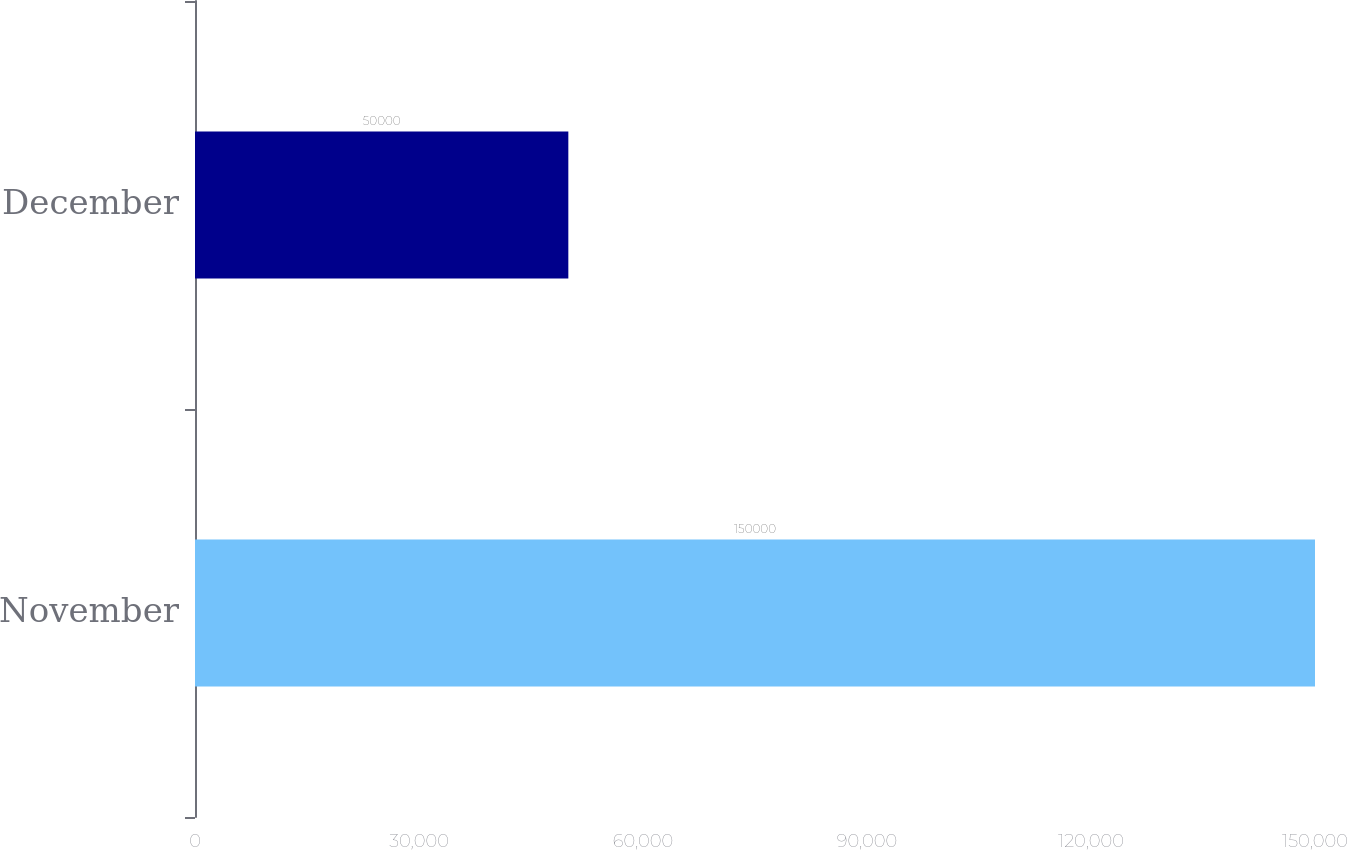Convert chart. <chart><loc_0><loc_0><loc_500><loc_500><bar_chart><fcel>November<fcel>December<nl><fcel>150000<fcel>50000<nl></chart> 